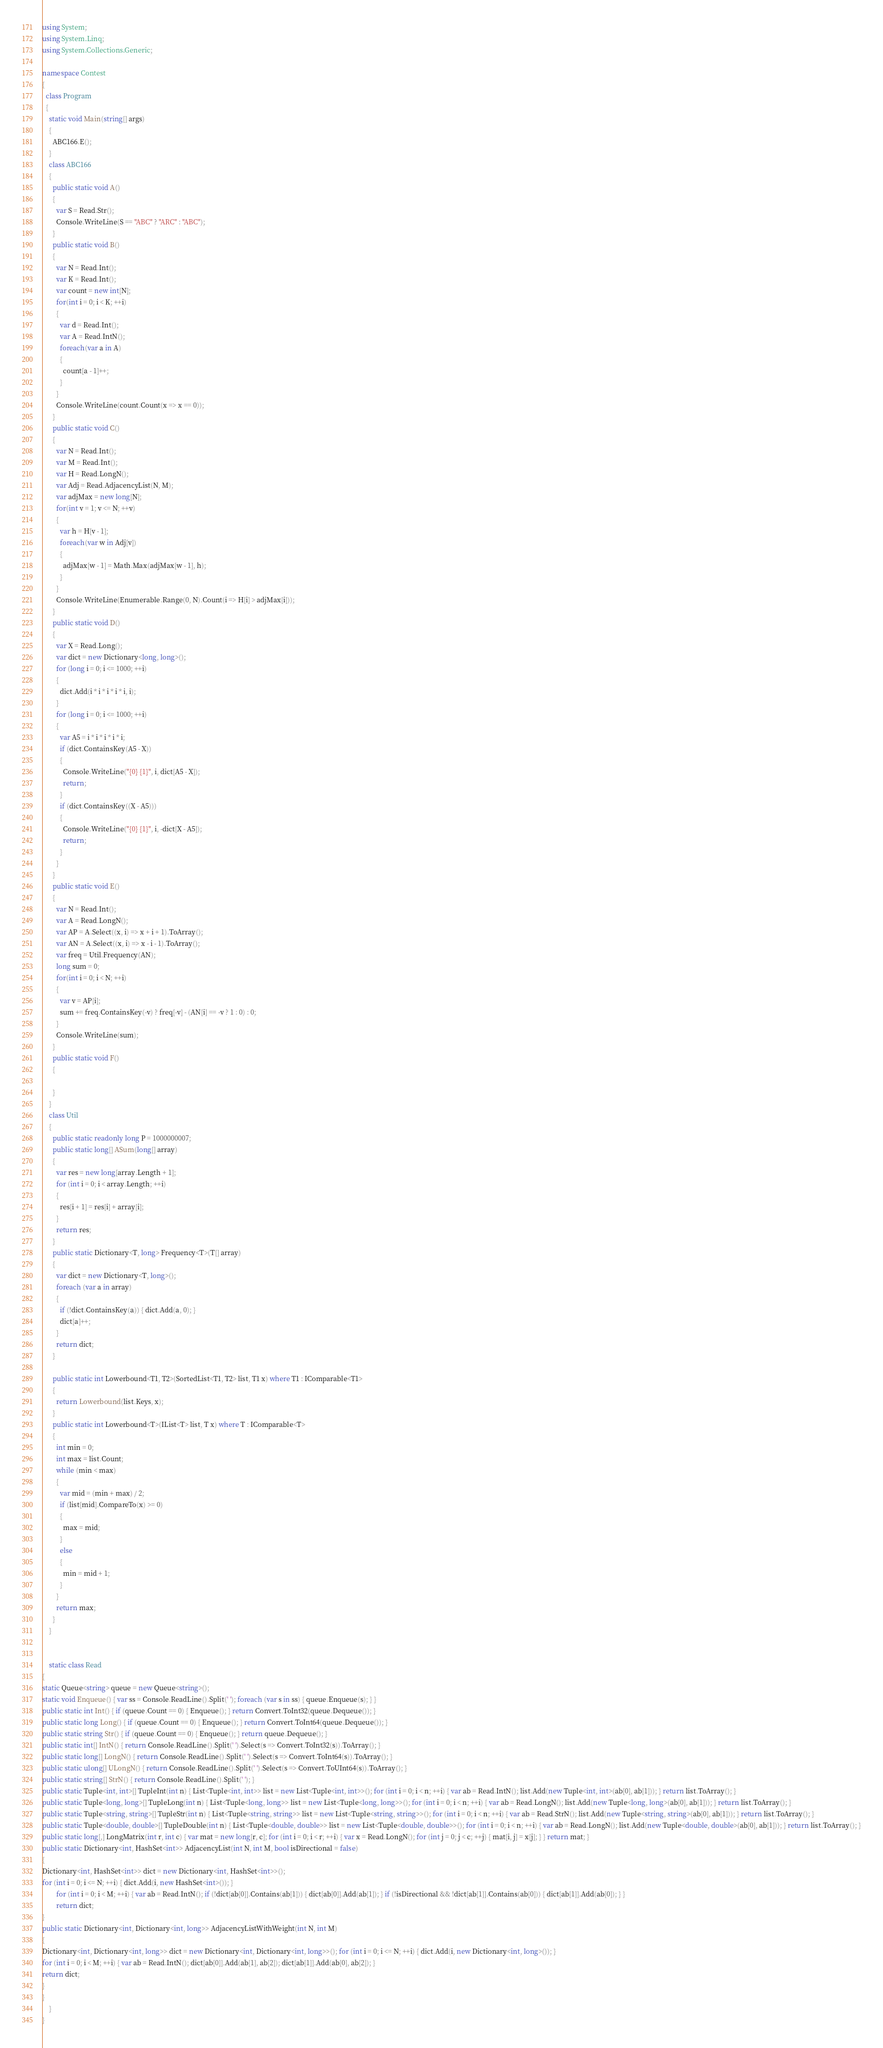Convert code to text. <code><loc_0><loc_0><loc_500><loc_500><_C#_>using System;
using System.Linq;
using System.Collections.Generic;

namespace Contest
{
  class Program
  {
    static void Main(string[] args)
    {
      ABC166.E();
    }
    class ABC166
    {
      public static void A()
      {
        var S = Read.Str();
        Console.WriteLine(S == "ABC" ? "ARC" : "ABC");
      }
      public static void B()
      {
        var N = Read.Int();
        var K = Read.Int();
        var count = new int[N];
        for(int i = 0; i < K; ++i)
        {
          var d = Read.Int();
          var A = Read.IntN();
          foreach(var a in A)
          {
            count[a - 1]++;
          }
        }
        Console.WriteLine(count.Count(x => x == 0));
      }
      public static void C()
      {
        var N = Read.Int();
        var M = Read.Int();
        var H = Read.LongN();
        var Adj = Read.AdjacencyList(N, M);
        var adjMax = new long[N];
        for(int v = 1; v <= N; ++v)
        {
          var h = H[v - 1];
          foreach(var w in Adj[v])
          {
            adjMax[w - 1] = Math.Max(adjMax[w - 1], h);
          }
        }
        Console.WriteLine(Enumerable.Range(0, N).Count(i => H[i] > adjMax[i]));
      }
      public static void D()
      {
        var X = Read.Long();
        var dict = new Dictionary<long, long>();
        for (long i = 0; i <= 1000; ++i)
        {
          dict.Add(i * i * i * i * i, i);
        }
        for (long i = 0; i <= 1000; ++i)
        {
          var A5 = i * i * i * i * i;
          if (dict.ContainsKey(A5 - X))
          {
            Console.WriteLine("{0} {1}", i, dict[A5 - X]);
            return;
          }
          if (dict.ContainsKey((X - A5)))
          {
            Console.WriteLine("{0} {1}", i, -dict[X - A5]);
            return;
          }
        }
      }
      public static void E()
      {
        var N = Read.Int();
        var A = Read.LongN();
        var AP = A.Select((x, i) => x + i + 1).ToArray();
        var AN = A.Select((x, i) => x - i - 1).ToArray();
        var freq = Util.Frequency(AN);
        long sum = 0;
        for(int i = 0; i < N; ++i)
        {
          var v = AP[i];
          sum += freq.ContainsKey(-v) ? freq[-v] - (AN[i] == -v ? 1 : 0) : 0;
        }
        Console.WriteLine(sum);
      }
      public static void F()
      {

      }
    }
    class Util
    {
      public static readonly long P = 1000000007;
      public static long[] ASum(long[] array)
      {
        var res = new long[array.Length + 1];
        for (int i = 0; i < array.Length; ++i)
        {
          res[i + 1] = res[i] + array[i];
        }
        return res;
      }
      public static Dictionary<T, long> Frequency<T>(T[] array)
      {
        var dict = new Dictionary<T, long>();
        foreach (var a in array)
        {
          if (!dict.ContainsKey(a)) { dict.Add(a, 0); }
          dict[a]++;
        }
        return dict;
      }

      public static int Lowerbound<T1, T2>(SortedList<T1, T2> list, T1 x) where T1 : IComparable<T1>
      {
        return Lowerbound(list.Keys, x);
      }
      public static int Lowerbound<T>(IList<T> list, T x) where T : IComparable<T>
      {
        int min = 0;
        int max = list.Count;
        while (min < max)
        {
          var mid = (min + max) / 2;
          if (list[mid].CompareTo(x) >= 0)
          {
            max = mid;
          }
          else
          {
            min = mid + 1;
          }
        }
        return max;
      }
    }


    static class Read
{
static Queue<string> queue = new Queue<string>();
static void Enqueue() { var ss = Console.ReadLine().Split(' '); foreach (var s in ss) { queue.Enqueue(s); } }
public static int Int() { if (queue.Count == 0) { Enqueue(); } return Convert.ToInt32(queue.Dequeue()); }
public static long Long() { if (queue.Count == 0) { Enqueue(); } return Convert.ToInt64(queue.Dequeue()); }
public static string Str() { if (queue.Count == 0) { Enqueue(); } return queue.Dequeue(); }
public static int[] IntN() { return Console.ReadLine().Split(' ').Select(s => Convert.ToInt32(s)).ToArray(); }
public static long[] LongN() { return Console.ReadLine().Split(' ').Select(s => Convert.ToInt64(s)).ToArray(); }
public static ulong[] ULongN() { return Console.ReadLine().Split(' ').Select(s => Convert.ToUInt64(s)).ToArray(); }
public static string[] StrN() { return Console.ReadLine().Split(' '); }
public static Tuple<int, int>[] TupleInt(int n) { List<Tuple<int, int>> list = new List<Tuple<int, int>>(); for (int i = 0; i < n; ++i) { var ab = Read.IntN(); list.Add(new Tuple<int, int>(ab[0], ab[1])); } return list.ToArray(); }
public static Tuple<long, long>[] TupleLong(int n) { List<Tuple<long, long>> list = new List<Tuple<long, long>>(); for (int i = 0; i < n; ++i) { var ab = Read.LongN(); list.Add(new Tuple<long, long>(ab[0], ab[1])); } return list.ToArray(); }
public static Tuple<string, string>[] TupleStr(int n) { List<Tuple<string, string>> list = new List<Tuple<string, string>>(); for (int i = 0; i < n; ++i) { var ab = Read.StrN(); list.Add(new Tuple<string, string>(ab[0], ab[1])); } return list.ToArray(); }
public static Tuple<double, double>[] TupleDouble(int n) { List<Tuple<double, double>> list = new List<Tuple<double, double>>(); for (int i = 0; i < n; ++i) { var ab = Read.LongN(); list.Add(new Tuple<double, double>(ab[0], ab[1])); } return list.ToArray(); }
public static long[,] LongMatrix(int r, int c) { var mat = new long[r, c]; for (int i = 0; i < r; ++i) { var x = Read.LongN(); for (int j = 0; j < c; ++j) { mat[i, j] = x[j]; } } return mat; }
public static Dictionary<int, HashSet<int>> AdjacencyList(int N, int M, bool isDirectional = false)
{
Dictionary<int, HashSet<int>> dict = new Dictionary<int, HashSet<int>>();
for (int i = 0; i <= N; ++i) { dict.Add(i, new HashSet<int>()); }
        for (int i = 0; i < M; ++i) { var ab = Read.IntN(); if (!dict[ab[0]].Contains(ab[1])) { dict[ab[0]].Add(ab[1]); } if (!isDirectional && !dict[ab[1]].Contains(ab[0])) { dict[ab[1]].Add(ab[0]); } }
        return dict;
}
public static Dictionary<int, Dictionary<int, long>> AdjacencyListWithWeight(int N, int M)
{
Dictionary<int, Dictionary<int, long>> dict = new Dictionary<int, Dictionary<int, long>>(); for (int i = 0; i <= N; ++i) { dict.Add(i, new Dictionary<int, long>()); }
for (int i = 0; i < M; ++i) { var ab = Read.IntN(); dict[ab[0]].Add(ab[1], ab[2]); dict[ab[1]].Add(ab[0], ab[2]); }
return dict;
}
}
    }
}
</code> 